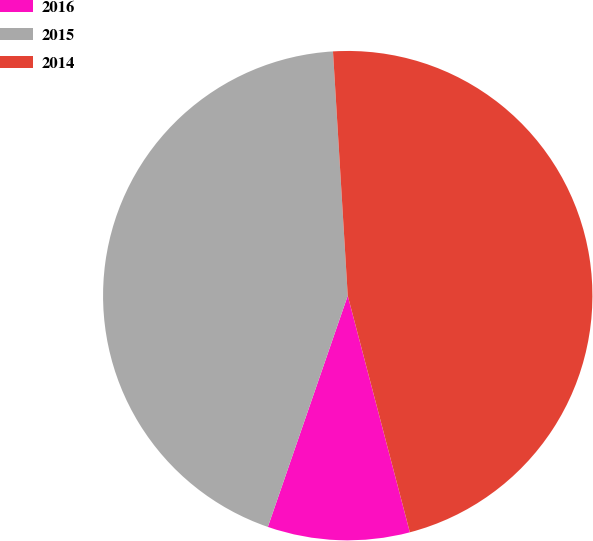<chart> <loc_0><loc_0><loc_500><loc_500><pie_chart><fcel>2016<fcel>2015<fcel>2014<nl><fcel>9.38%<fcel>43.75%<fcel>46.88%<nl></chart> 